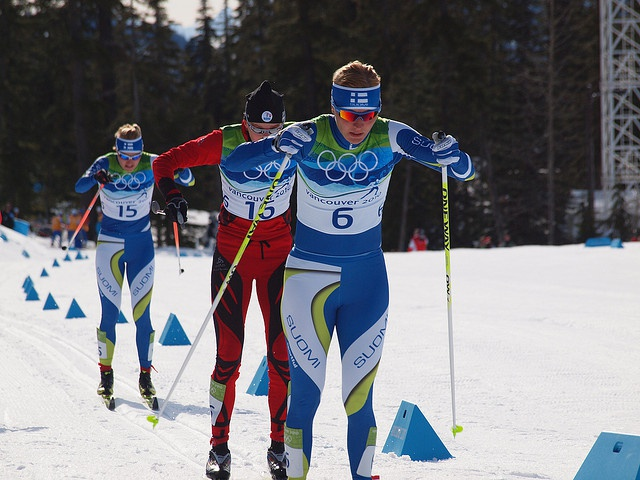Describe the objects in this image and their specific colors. I can see people in black, navy, darkgray, and blue tones, people in black, maroon, and darkgray tones, people in black, navy, and darkgray tones, skis in black, gray, darkgray, and white tones, and people in black and gray tones in this image. 